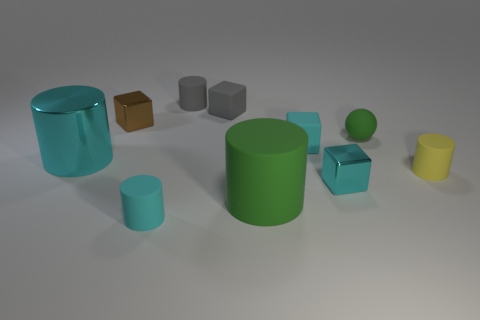Subtract all yellow cylinders. How many cylinders are left? 4 Subtract all large cyan cylinders. How many cylinders are left? 4 Subtract all red cylinders. Subtract all red balls. How many cylinders are left? 5 Subtract all spheres. How many objects are left? 9 Add 7 big purple metallic spheres. How many big purple metallic spheres exist? 7 Subtract 1 gray cylinders. How many objects are left? 9 Subtract all big blue shiny things. Subtract all cyan cubes. How many objects are left? 8 Add 8 cyan cylinders. How many cyan cylinders are left? 10 